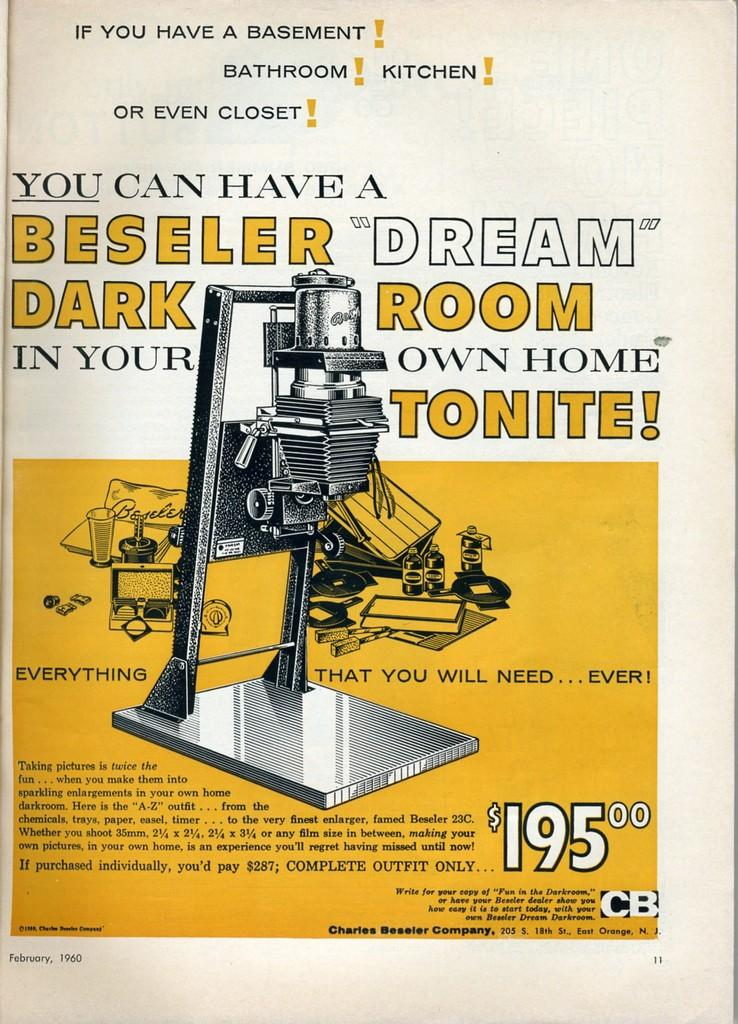<image>
Write a terse but informative summary of the picture. An ad from the CB Company, claims it can provide all you need for a complete home darkroom for $195. 